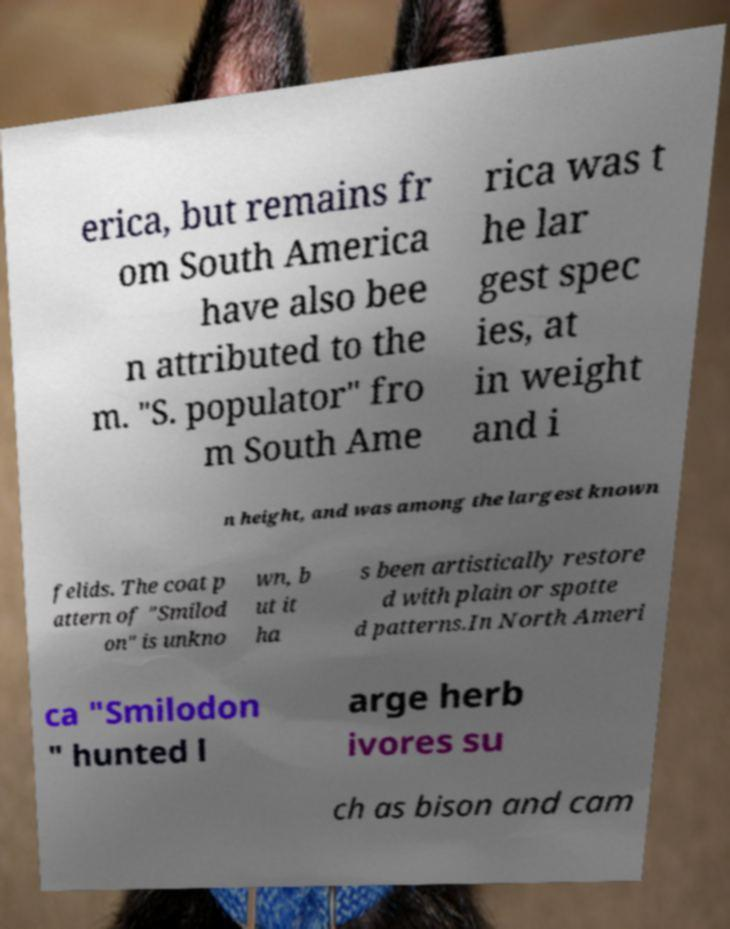Can you accurately transcribe the text from the provided image for me? erica, but remains fr om South America have also bee n attributed to the m. "S. populator" fro m South Ame rica was t he lar gest spec ies, at in weight and i n height, and was among the largest known felids. The coat p attern of "Smilod on" is unkno wn, b ut it ha s been artistically restore d with plain or spotte d patterns.In North Ameri ca "Smilodon " hunted l arge herb ivores su ch as bison and cam 